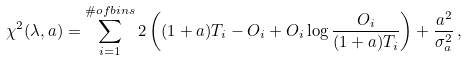<formula> <loc_0><loc_0><loc_500><loc_500>\chi ^ { 2 } ( \lambda , a ) = \sum _ { i = 1 } ^ { \# o f b i n s } 2 \left ( ( 1 + a ) T _ { i } - O _ { i } + O _ { i } \log \frac { O _ { i } } { ( 1 + a ) T _ { i } } \right ) + \frac { a ^ { 2 } } { \sigma _ { a } ^ { 2 } } \, ,</formula> 